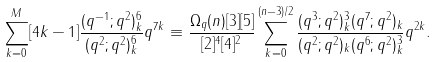<formula> <loc_0><loc_0><loc_500><loc_500>\sum _ { k = 0 } ^ { M } [ 4 k - 1 ] \frac { ( q ^ { - 1 } ; q ^ { 2 } ) _ { k } ^ { 6 } } { ( q ^ { 2 } ; q ^ { 2 } ) _ { k } ^ { 6 } } q ^ { 7 k } \equiv \frac { \Omega _ { q } ( n ) [ 3 ] [ 5 ] } { [ 2 ] ^ { 4 } [ 4 ] ^ { 2 } } \sum _ { k = 0 } ^ { ( n - 3 ) / 2 } \frac { ( q ^ { 3 } ; q ^ { 2 } ) _ { k } ^ { 3 } ( q ^ { 7 } ; q ^ { 2 } ) _ { k } } { ( q ^ { 2 } ; q ^ { 2 } ) _ { k } ( q ^ { 6 } ; q ^ { 2 } ) _ { k } ^ { 3 } } q ^ { 2 k } .</formula> 